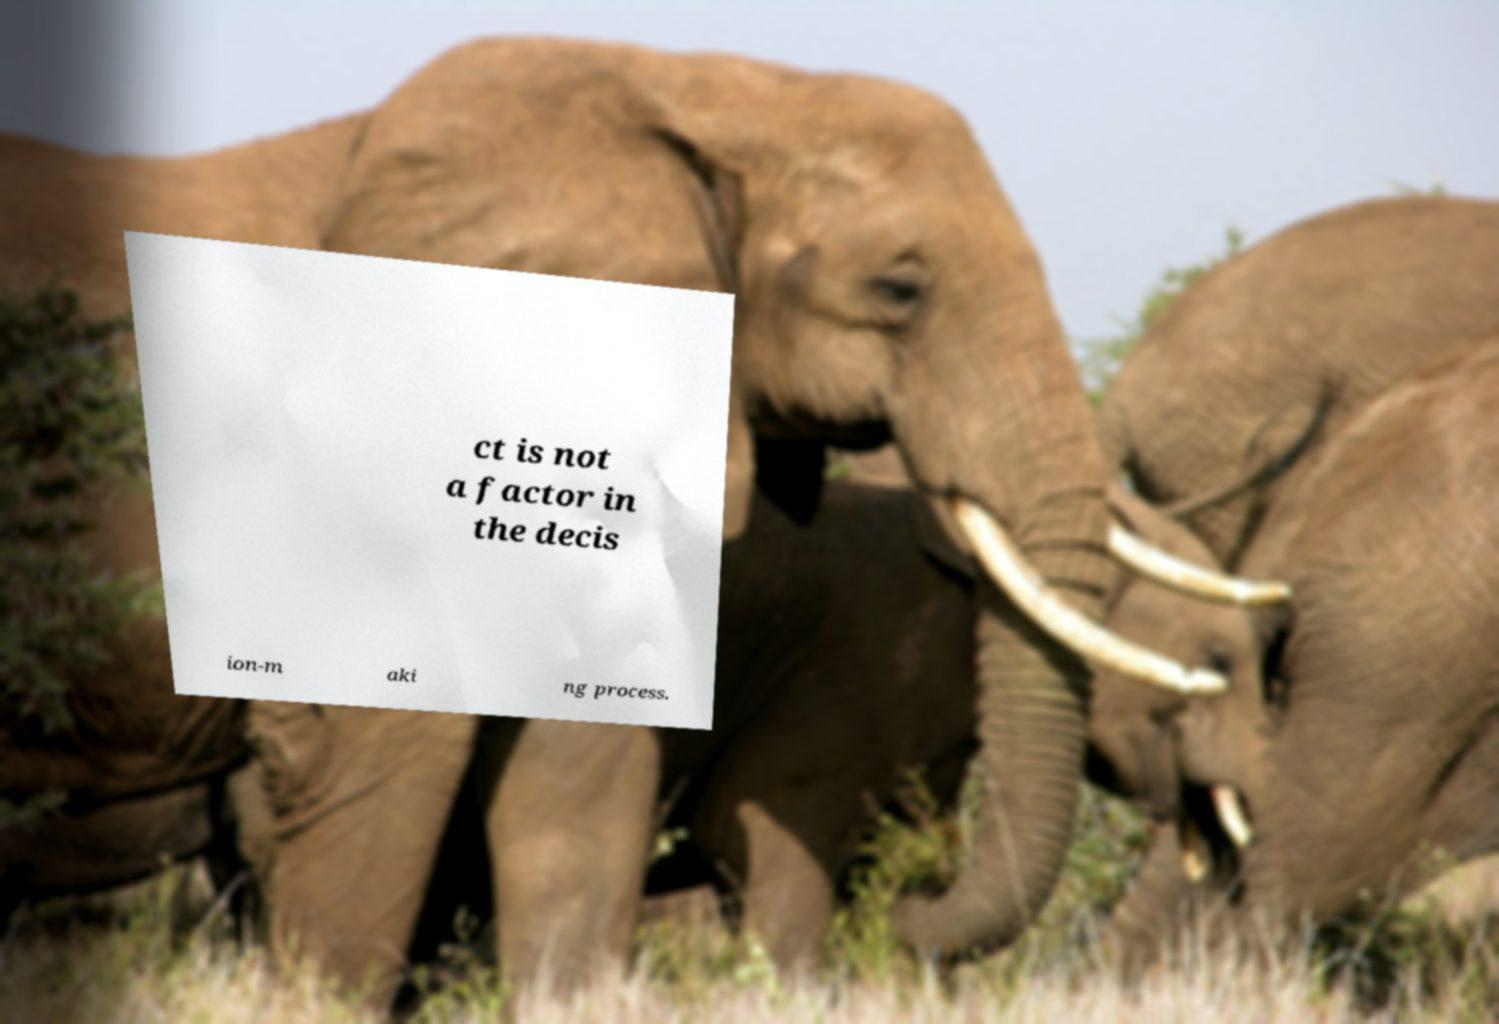Please identify and transcribe the text found in this image. ct is not a factor in the decis ion-m aki ng process. 